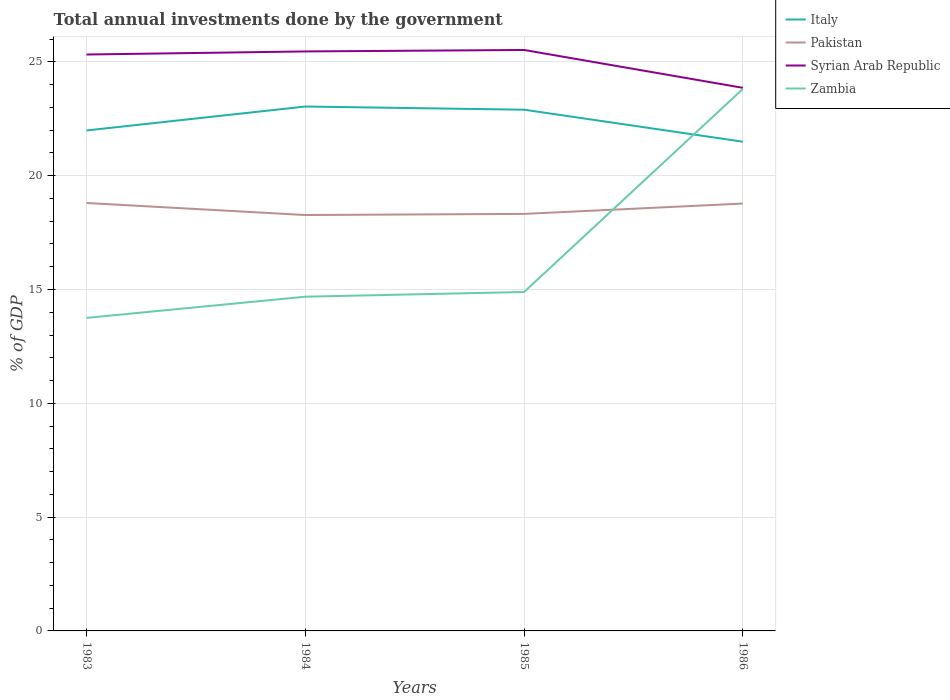Is the number of lines equal to the number of legend labels?
Keep it short and to the point. Yes. Across all years, what is the maximum total annual investments done by the government in Zambia?
Offer a very short reply. 13.75. In which year was the total annual investments done by the government in Zambia maximum?
Your answer should be compact. 1983. What is the total total annual investments done by the government in Pakistan in the graph?
Ensure brevity in your answer.  -0.5. What is the difference between the highest and the second highest total annual investments done by the government in Pakistan?
Keep it short and to the point. 0.53. Is the total annual investments done by the government in Pakistan strictly greater than the total annual investments done by the government in Syrian Arab Republic over the years?
Keep it short and to the point. Yes. How many lines are there?
Make the answer very short. 4. What is the difference between two consecutive major ticks on the Y-axis?
Your response must be concise. 5. Does the graph contain grids?
Offer a very short reply. Yes. Where does the legend appear in the graph?
Give a very brief answer. Top right. How many legend labels are there?
Offer a terse response. 4. How are the legend labels stacked?
Your response must be concise. Vertical. What is the title of the graph?
Provide a short and direct response. Total annual investments done by the government. What is the label or title of the X-axis?
Provide a short and direct response. Years. What is the label or title of the Y-axis?
Ensure brevity in your answer.  % of GDP. What is the % of GDP in Italy in 1983?
Your answer should be compact. 21.99. What is the % of GDP in Pakistan in 1983?
Provide a succinct answer. 18.8. What is the % of GDP in Syrian Arab Republic in 1983?
Make the answer very short. 25.32. What is the % of GDP in Zambia in 1983?
Keep it short and to the point. 13.75. What is the % of GDP of Italy in 1984?
Your answer should be compact. 23.04. What is the % of GDP of Pakistan in 1984?
Provide a succinct answer. 18.27. What is the % of GDP in Syrian Arab Republic in 1984?
Your response must be concise. 25.46. What is the % of GDP in Zambia in 1984?
Make the answer very short. 14.68. What is the % of GDP in Italy in 1985?
Your answer should be very brief. 22.9. What is the % of GDP in Pakistan in 1985?
Your response must be concise. 18.32. What is the % of GDP in Syrian Arab Republic in 1985?
Offer a terse response. 25.52. What is the % of GDP of Zambia in 1985?
Your answer should be compact. 14.89. What is the % of GDP of Italy in 1986?
Provide a succinct answer. 21.49. What is the % of GDP of Pakistan in 1986?
Your answer should be compact. 18.77. What is the % of GDP in Syrian Arab Republic in 1986?
Your answer should be compact. 23.86. What is the % of GDP in Zambia in 1986?
Your answer should be compact. 23.81. Across all years, what is the maximum % of GDP of Italy?
Offer a terse response. 23.04. Across all years, what is the maximum % of GDP in Pakistan?
Your response must be concise. 18.8. Across all years, what is the maximum % of GDP in Syrian Arab Republic?
Offer a terse response. 25.52. Across all years, what is the maximum % of GDP in Zambia?
Offer a terse response. 23.81. Across all years, what is the minimum % of GDP in Italy?
Give a very brief answer. 21.49. Across all years, what is the minimum % of GDP of Pakistan?
Give a very brief answer. 18.27. Across all years, what is the minimum % of GDP in Syrian Arab Republic?
Make the answer very short. 23.86. Across all years, what is the minimum % of GDP in Zambia?
Keep it short and to the point. 13.75. What is the total % of GDP in Italy in the graph?
Offer a terse response. 89.41. What is the total % of GDP in Pakistan in the graph?
Offer a terse response. 74.16. What is the total % of GDP of Syrian Arab Republic in the graph?
Give a very brief answer. 100.16. What is the total % of GDP in Zambia in the graph?
Provide a short and direct response. 67.14. What is the difference between the % of GDP of Italy in 1983 and that in 1984?
Provide a short and direct response. -1.05. What is the difference between the % of GDP in Pakistan in 1983 and that in 1984?
Make the answer very short. 0.53. What is the difference between the % of GDP in Syrian Arab Republic in 1983 and that in 1984?
Your response must be concise. -0.14. What is the difference between the % of GDP of Zambia in 1983 and that in 1984?
Provide a succinct answer. -0.93. What is the difference between the % of GDP of Italy in 1983 and that in 1985?
Your answer should be very brief. -0.91. What is the difference between the % of GDP of Pakistan in 1983 and that in 1985?
Keep it short and to the point. 0.48. What is the difference between the % of GDP of Syrian Arab Republic in 1983 and that in 1985?
Provide a succinct answer. -0.2. What is the difference between the % of GDP in Zambia in 1983 and that in 1985?
Keep it short and to the point. -1.14. What is the difference between the % of GDP of Italy in 1983 and that in 1986?
Give a very brief answer. 0.49. What is the difference between the % of GDP in Pakistan in 1983 and that in 1986?
Provide a succinct answer. 0.03. What is the difference between the % of GDP in Syrian Arab Republic in 1983 and that in 1986?
Keep it short and to the point. 1.46. What is the difference between the % of GDP of Zambia in 1983 and that in 1986?
Give a very brief answer. -10.06. What is the difference between the % of GDP of Italy in 1984 and that in 1985?
Ensure brevity in your answer.  0.14. What is the difference between the % of GDP in Pakistan in 1984 and that in 1985?
Provide a short and direct response. -0.05. What is the difference between the % of GDP of Syrian Arab Republic in 1984 and that in 1985?
Provide a succinct answer. -0.06. What is the difference between the % of GDP in Zambia in 1984 and that in 1985?
Your answer should be very brief. -0.21. What is the difference between the % of GDP in Italy in 1984 and that in 1986?
Your answer should be very brief. 1.55. What is the difference between the % of GDP in Pakistan in 1984 and that in 1986?
Provide a succinct answer. -0.5. What is the difference between the % of GDP in Syrian Arab Republic in 1984 and that in 1986?
Your response must be concise. 1.6. What is the difference between the % of GDP of Zambia in 1984 and that in 1986?
Ensure brevity in your answer.  -9.13. What is the difference between the % of GDP in Italy in 1985 and that in 1986?
Provide a succinct answer. 1.41. What is the difference between the % of GDP of Pakistan in 1985 and that in 1986?
Offer a very short reply. -0.45. What is the difference between the % of GDP of Syrian Arab Republic in 1985 and that in 1986?
Provide a succinct answer. 1.66. What is the difference between the % of GDP in Zambia in 1985 and that in 1986?
Provide a succinct answer. -8.92. What is the difference between the % of GDP of Italy in 1983 and the % of GDP of Pakistan in 1984?
Ensure brevity in your answer.  3.72. What is the difference between the % of GDP of Italy in 1983 and the % of GDP of Syrian Arab Republic in 1984?
Offer a very short reply. -3.47. What is the difference between the % of GDP of Italy in 1983 and the % of GDP of Zambia in 1984?
Provide a succinct answer. 7.3. What is the difference between the % of GDP in Pakistan in 1983 and the % of GDP in Syrian Arab Republic in 1984?
Provide a succinct answer. -6.66. What is the difference between the % of GDP in Pakistan in 1983 and the % of GDP in Zambia in 1984?
Your answer should be very brief. 4.12. What is the difference between the % of GDP of Syrian Arab Republic in 1983 and the % of GDP of Zambia in 1984?
Ensure brevity in your answer.  10.64. What is the difference between the % of GDP in Italy in 1983 and the % of GDP in Pakistan in 1985?
Offer a very short reply. 3.67. What is the difference between the % of GDP of Italy in 1983 and the % of GDP of Syrian Arab Republic in 1985?
Ensure brevity in your answer.  -3.54. What is the difference between the % of GDP in Italy in 1983 and the % of GDP in Zambia in 1985?
Provide a short and direct response. 7.1. What is the difference between the % of GDP of Pakistan in 1983 and the % of GDP of Syrian Arab Republic in 1985?
Provide a short and direct response. -6.72. What is the difference between the % of GDP in Pakistan in 1983 and the % of GDP in Zambia in 1985?
Provide a succinct answer. 3.91. What is the difference between the % of GDP in Syrian Arab Republic in 1983 and the % of GDP in Zambia in 1985?
Make the answer very short. 10.43. What is the difference between the % of GDP in Italy in 1983 and the % of GDP in Pakistan in 1986?
Offer a terse response. 3.21. What is the difference between the % of GDP of Italy in 1983 and the % of GDP of Syrian Arab Republic in 1986?
Provide a short and direct response. -1.87. What is the difference between the % of GDP of Italy in 1983 and the % of GDP of Zambia in 1986?
Give a very brief answer. -1.82. What is the difference between the % of GDP of Pakistan in 1983 and the % of GDP of Syrian Arab Republic in 1986?
Give a very brief answer. -5.06. What is the difference between the % of GDP in Pakistan in 1983 and the % of GDP in Zambia in 1986?
Provide a succinct answer. -5.01. What is the difference between the % of GDP in Syrian Arab Republic in 1983 and the % of GDP in Zambia in 1986?
Ensure brevity in your answer.  1.51. What is the difference between the % of GDP in Italy in 1984 and the % of GDP in Pakistan in 1985?
Offer a very short reply. 4.72. What is the difference between the % of GDP of Italy in 1984 and the % of GDP of Syrian Arab Republic in 1985?
Offer a very short reply. -2.48. What is the difference between the % of GDP in Italy in 1984 and the % of GDP in Zambia in 1985?
Your answer should be compact. 8.15. What is the difference between the % of GDP of Pakistan in 1984 and the % of GDP of Syrian Arab Republic in 1985?
Keep it short and to the point. -7.25. What is the difference between the % of GDP of Pakistan in 1984 and the % of GDP of Zambia in 1985?
Keep it short and to the point. 3.38. What is the difference between the % of GDP of Syrian Arab Republic in 1984 and the % of GDP of Zambia in 1985?
Make the answer very short. 10.57. What is the difference between the % of GDP of Italy in 1984 and the % of GDP of Pakistan in 1986?
Give a very brief answer. 4.26. What is the difference between the % of GDP in Italy in 1984 and the % of GDP in Syrian Arab Republic in 1986?
Your answer should be compact. -0.82. What is the difference between the % of GDP of Italy in 1984 and the % of GDP of Zambia in 1986?
Your answer should be compact. -0.77. What is the difference between the % of GDP of Pakistan in 1984 and the % of GDP of Syrian Arab Republic in 1986?
Provide a short and direct response. -5.59. What is the difference between the % of GDP of Pakistan in 1984 and the % of GDP of Zambia in 1986?
Provide a succinct answer. -5.54. What is the difference between the % of GDP of Syrian Arab Republic in 1984 and the % of GDP of Zambia in 1986?
Your answer should be compact. 1.65. What is the difference between the % of GDP of Italy in 1985 and the % of GDP of Pakistan in 1986?
Keep it short and to the point. 4.12. What is the difference between the % of GDP of Italy in 1985 and the % of GDP of Syrian Arab Republic in 1986?
Provide a succinct answer. -0.96. What is the difference between the % of GDP of Italy in 1985 and the % of GDP of Zambia in 1986?
Your response must be concise. -0.91. What is the difference between the % of GDP in Pakistan in 1985 and the % of GDP in Syrian Arab Republic in 1986?
Provide a succinct answer. -5.54. What is the difference between the % of GDP of Pakistan in 1985 and the % of GDP of Zambia in 1986?
Ensure brevity in your answer.  -5.49. What is the difference between the % of GDP in Syrian Arab Republic in 1985 and the % of GDP in Zambia in 1986?
Keep it short and to the point. 1.71. What is the average % of GDP in Italy per year?
Your response must be concise. 22.35. What is the average % of GDP of Pakistan per year?
Your answer should be compact. 18.54. What is the average % of GDP of Syrian Arab Republic per year?
Give a very brief answer. 25.04. What is the average % of GDP in Zambia per year?
Your answer should be compact. 16.78. In the year 1983, what is the difference between the % of GDP of Italy and % of GDP of Pakistan?
Provide a succinct answer. 3.19. In the year 1983, what is the difference between the % of GDP in Italy and % of GDP in Syrian Arab Republic?
Your answer should be very brief. -3.34. In the year 1983, what is the difference between the % of GDP of Italy and % of GDP of Zambia?
Give a very brief answer. 8.23. In the year 1983, what is the difference between the % of GDP in Pakistan and % of GDP in Syrian Arab Republic?
Your answer should be very brief. -6.52. In the year 1983, what is the difference between the % of GDP in Pakistan and % of GDP in Zambia?
Offer a very short reply. 5.05. In the year 1983, what is the difference between the % of GDP in Syrian Arab Republic and % of GDP in Zambia?
Your answer should be very brief. 11.57. In the year 1984, what is the difference between the % of GDP of Italy and % of GDP of Pakistan?
Provide a short and direct response. 4.77. In the year 1984, what is the difference between the % of GDP of Italy and % of GDP of Syrian Arab Republic?
Offer a very short reply. -2.42. In the year 1984, what is the difference between the % of GDP of Italy and % of GDP of Zambia?
Your response must be concise. 8.35. In the year 1984, what is the difference between the % of GDP of Pakistan and % of GDP of Syrian Arab Republic?
Your response must be concise. -7.19. In the year 1984, what is the difference between the % of GDP in Pakistan and % of GDP in Zambia?
Ensure brevity in your answer.  3.59. In the year 1984, what is the difference between the % of GDP of Syrian Arab Republic and % of GDP of Zambia?
Your response must be concise. 10.77. In the year 1985, what is the difference between the % of GDP in Italy and % of GDP in Pakistan?
Ensure brevity in your answer.  4.58. In the year 1985, what is the difference between the % of GDP in Italy and % of GDP in Syrian Arab Republic?
Your response must be concise. -2.62. In the year 1985, what is the difference between the % of GDP of Italy and % of GDP of Zambia?
Your answer should be compact. 8.01. In the year 1985, what is the difference between the % of GDP of Pakistan and % of GDP of Syrian Arab Republic?
Provide a short and direct response. -7.2. In the year 1985, what is the difference between the % of GDP in Pakistan and % of GDP in Zambia?
Give a very brief answer. 3.43. In the year 1985, what is the difference between the % of GDP of Syrian Arab Republic and % of GDP of Zambia?
Offer a terse response. 10.63. In the year 1986, what is the difference between the % of GDP in Italy and % of GDP in Pakistan?
Give a very brief answer. 2.72. In the year 1986, what is the difference between the % of GDP in Italy and % of GDP in Syrian Arab Republic?
Provide a short and direct response. -2.37. In the year 1986, what is the difference between the % of GDP of Italy and % of GDP of Zambia?
Keep it short and to the point. -2.32. In the year 1986, what is the difference between the % of GDP of Pakistan and % of GDP of Syrian Arab Republic?
Your response must be concise. -5.08. In the year 1986, what is the difference between the % of GDP of Pakistan and % of GDP of Zambia?
Provide a short and direct response. -5.04. In the year 1986, what is the difference between the % of GDP of Syrian Arab Republic and % of GDP of Zambia?
Give a very brief answer. 0.05. What is the ratio of the % of GDP in Italy in 1983 to that in 1984?
Your answer should be very brief. 0.95. What is the ratio of the % of GDP of Pakistan in 1983 to that in 1984?
Make the answer very short. 1.03. What is the ratio of the % of GDP of Zambia in 1983 to that in 1984?
Your response must be concise. 0.94. What is the ratio of the % of GDP in Italy in 1983 to that in 1985?
Provide a short and direct response. 0.96. What is the ratio of the % of GDP in Pakistan in 1983 to that in 1985?
Provide a succinct answer. 1.03. What is the ratio of the % of GDP in Syrian Arab Republic in 1983 to that in 1985?
Ensure brevity in your answer.  0.99. What is the ratio of the % of GDP in Zambia in 1983 to that in 1985?
Provide a succinct answer. 0.92. What is the ratio of the % of GDP in Italy in 1983 to that in 1986?
Your response must be concise. 1.02. What is the ratio of the % of GDP in Pakistan in 1983 to that in 1986?
Give a very brief answer. 1. What is the ratio of the % of GDP in Syrian Arab Republic in 1983 to that in 1986?
Your response must be concise. 1.06. What is the ratio of the % of GDP in Zambia in 1983 to that in 1986?
Your response must be concise. 0.58. What is the ratio of the % of GDP of Pakistan in 1984 to that in 1985?
Make the answer very short. 1. What is the ratio of the % of GDP of Zambia in 1984 to that in 1985?
Your answer should be very brief. 0.99. What is the ratio of the % of GDP of Italy in 1984 to that in 1986?
Offer a very short reply. 1.07. What is the ratio of the % of GDP of Pakistan in 1984 to that in 1986?
Give a very brief answer. 0.97. What is the ratio of the % of GDP of Syrian Arab Republic in 1984 to that in 1986?
Your response must be concise. 1.07. What is the ratio of the % of GDP of Zambia in 1984 to that in 1986?
Make the answer very short. 0.62. What is the ratio of the % of GDP in Italy in 1985 to that in 1986?
Offer a terse response. 1.07. What is the ratio of the % of GDP of Pakistan in 1985 to that in 1986?
Your answer should be compact. 0.98. What is the ratio of the % of GDP in Syrian Arab Republic in 1985 to that in 1986?
Your answer should be very brief. 1.07. What is the ratio of the % of GDP of Zambia in 1985 to that in 1986?
Offer a terse response. 0.63. What is the difference between the highest and the second highest % of GDP of Italy?
Provide a succinct answer. 0.14. What is the difference between the highest and the second highest % of GDP of Pakistan?
Your answer should be compact. 0.03. What is the difference between the highest and the second highest % of GDP of Syrian Arab Republic?
Make the answer very short. 0.06. What is the difference between the highest and the second highest % of GDP in Zambia?
Offer a terse response. 8.92. What is the difference between the highest and the lowest % of GDP in Italy?
Make the answer very short. 1.55. What is the difference between the highest and the lowest % of GDP of Pakistan?
Your answer should be compact. 0.53. What is the difference between the highest and the lowest % of GDP of Syrian Arab Republic?
Your answer should be very brief. 1.66. What is the difference between the highest and the lowest % of GDP of Zambia?
Provide a succinct answer. 10.06. 